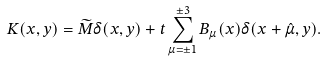Convert formula to latex. <formula><loc_0><loc_0><loc_500><loc_500>K ( x , y ) = \widetilde { M } \delta ( x , y ) + t \sum _ { \mu = \pm 1 } ^ { \pm 3 } B _ { \mu } ( x ) \delta ( x + \hat { \mu } , y ) .</formula> 